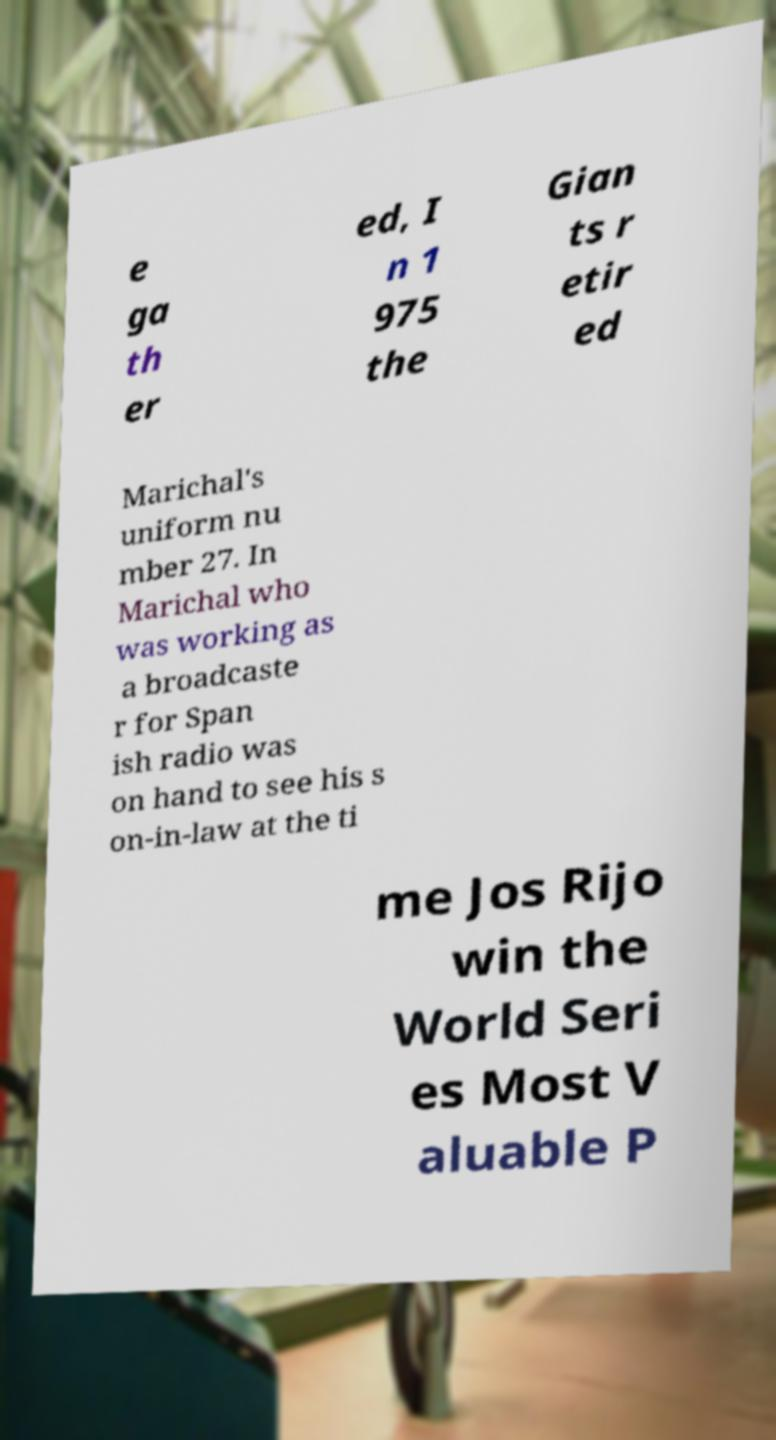What messages or text are displayed in this image? I need them in a readable, typed format. e ga th er ed, I n 1 975 the Gian ts r etir ed Marichal's uniform nu mber 27. In Marichal who was working as a broadcaste r for Span ish radio was on hand to see his s on-in-law at the ti me Jos Rijo win the World Seri es Most V aluable P 